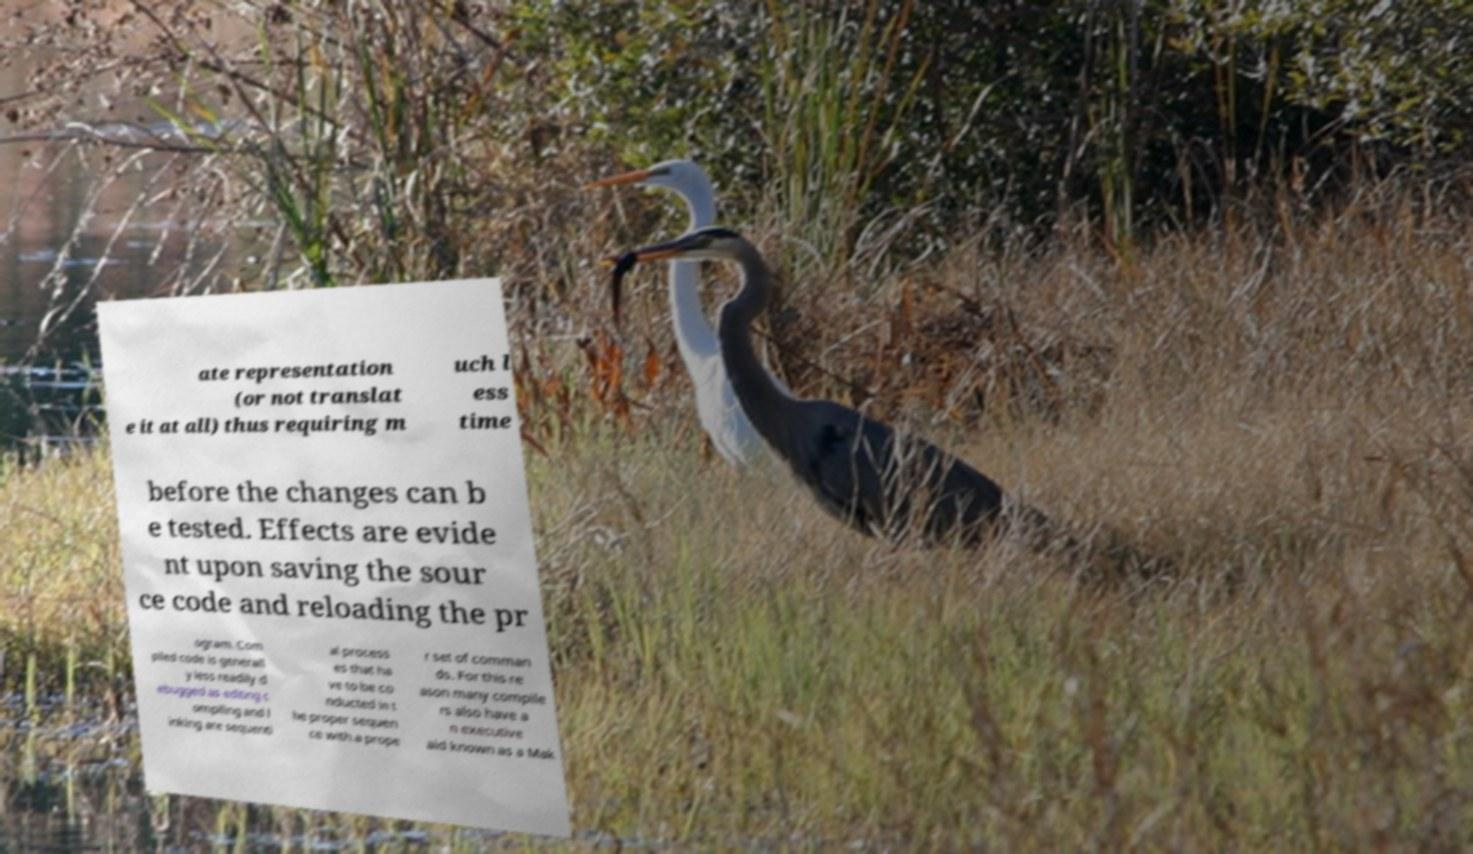Can you read and provide the text displayed in the image?This photo seems to have some interesting text. Can you extract and type it out for me? ate representation (or not translat e it at all) thus requiring m uch l ess time before the changes can b e tested. Effects are evide nt upon saving the sour ce code and reloading the pr ogram. Com piled code is generall y less readily d ebugged as editing c ompiling and l inking are sequenti al process es that ha ve to be co nducted in t he proper sequen ce with a prope r set of comman ds. For this re ason many compile rs also have a n executive aid known as a Mak 